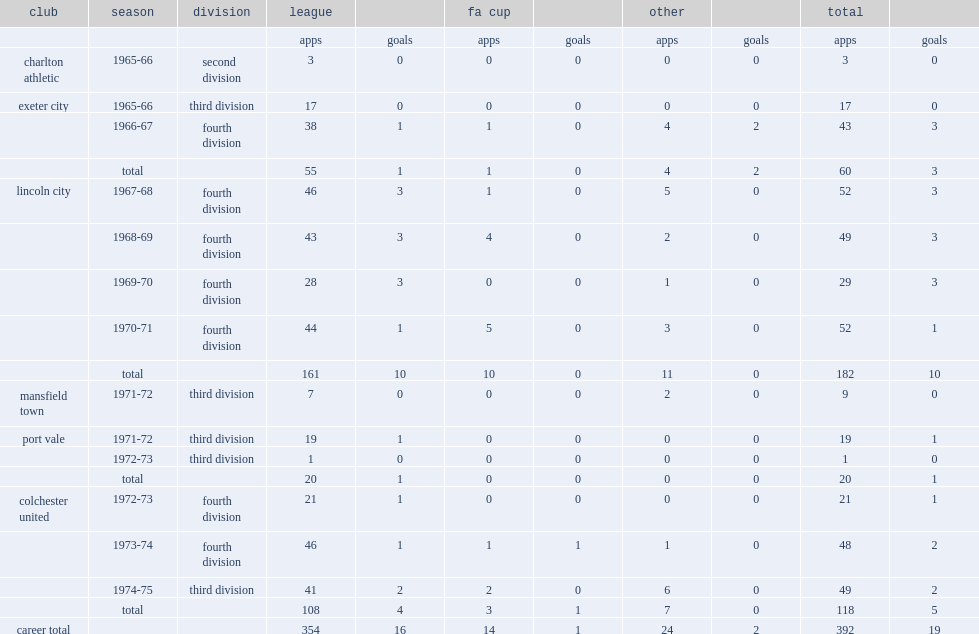Which club did ray harford move to after he play with lincoln city by making 161 league appearances for the club? Mansfield town. 